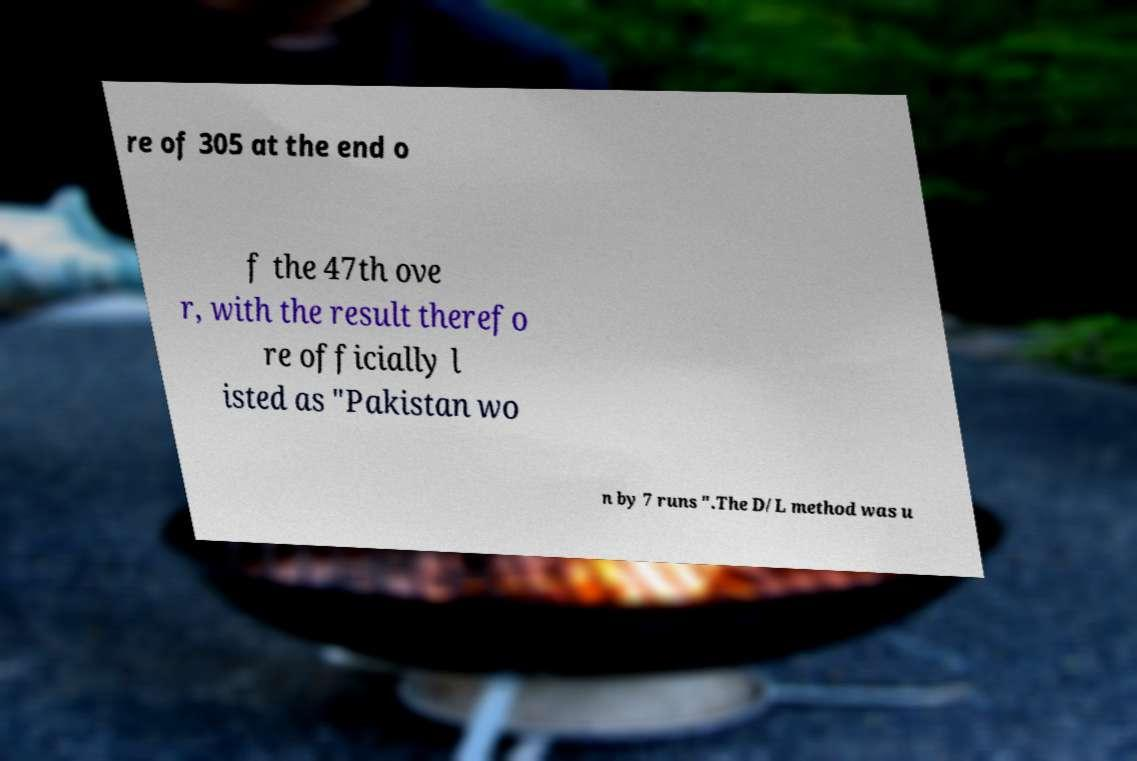Could you assist in decoding the text presented in this image and type it out clearly? re of 305 at the end o f the 47th ove r, with the result therefo re officially l isted as "Pakistan wo n by 7 runs ".The D/L method was u 